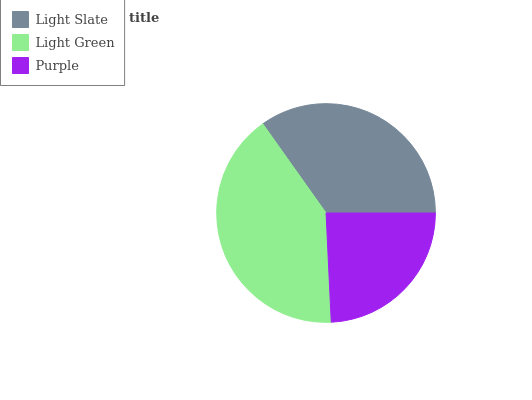Is Purple the minimum?
Answer yes or no. Yes. Is Light Green the maximum?
Answer yes or no. Yes. Is Light Green the minimum?
Answer yes or no. No. Is Purple the maximum?
Answer yes or no. No. Is Light Green greater than Purple?
Answer yes or no. Yes. Is Purple less than Light Green?
Answer yes or no. Yes. Is Purple greater than Light Green?
Answer yes or no. No. Is Light Green less than Purple?
Answer yes or no. No. Is Light Slate the high median?
Answer yes or no. Yes. Is Light Slate the low median?
Answer yes or no. Yes. Is Light Green the high median?
Answer yes or no. No. Is Purple the low median?
Answer yes or no. No. 